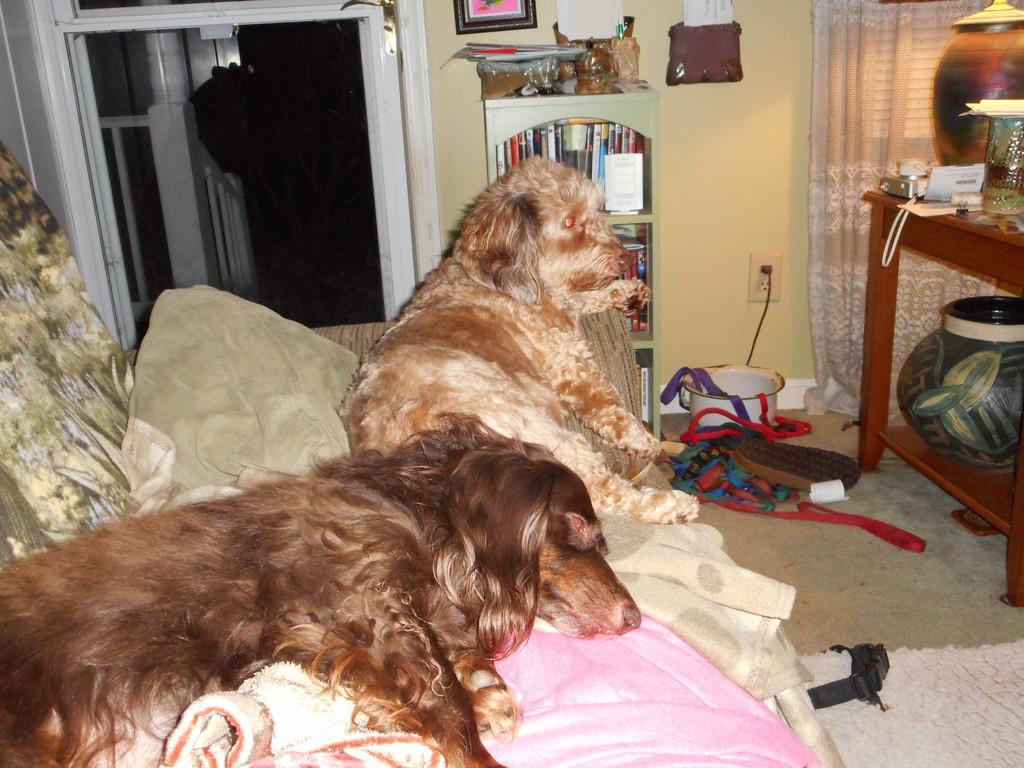How would you summarize this image in a sentence or two? In the left middle, a sofa is there on which two dogs are sleeping and cushions are kept. In the top a door is visible. In the middle a wall is visible light yellow in color and a curtain visible. In the right, a table is there on which paper, glass, electronic items are kept. In the middle, a stand is there in which books are kept. This image is taken inside a room. 